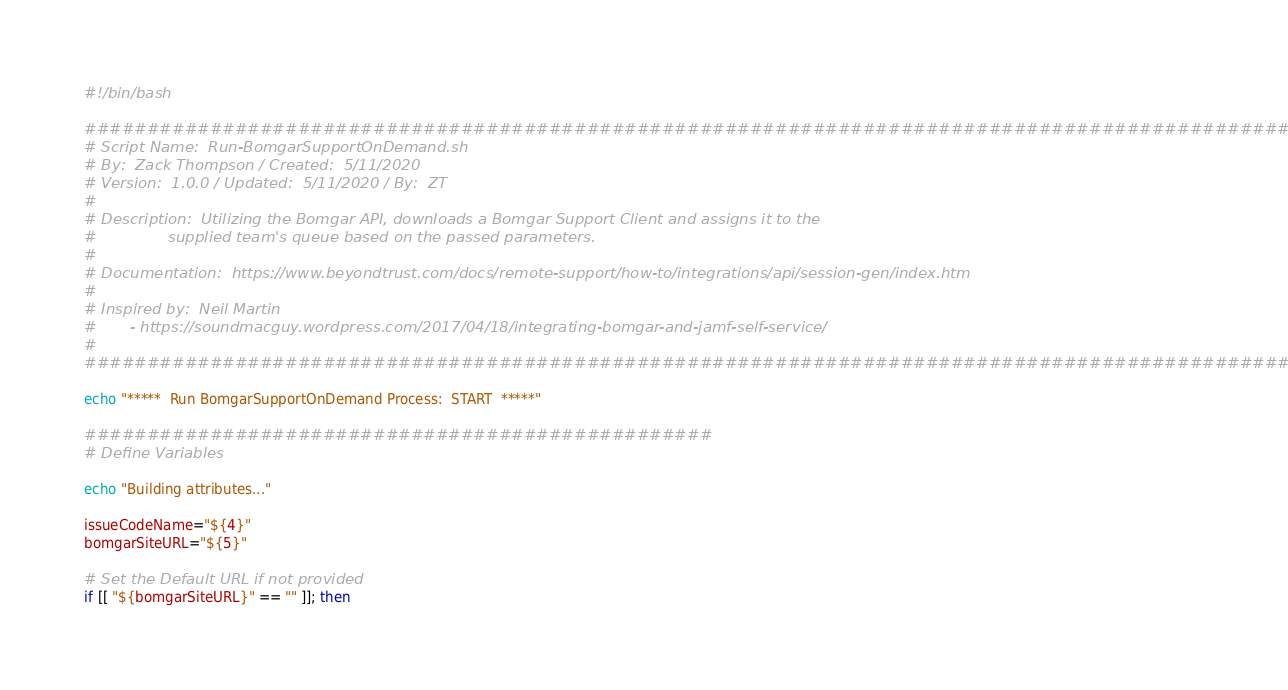Convert code to text. <code><loc_0><loc_0><loc_500><loc_500><_Bash_>#!/bin/bash

###################################################################################################
# Script Name:  Run-BomgarSupportOnDemand.sh
# By:  Zack Thompson / Created:  5/11/2020
# Version:  1.0.0 / Updated:  5/11/2020 / By:  ZT
#
# Description:  Utilizing the Bomgar API, downloads a Bomgar Support Client and assigns it to the
#               supplied team's queue based on the passed parameters.
#
# Documentation:  https://www.beyondtrust.com/docs/remote-support/how-to/integrations/api/session-gen/index.htm
#
# Inspired by:  Neil Martin
#       - https://soundmacguy.wordpress.com/2017/04/18/integrating-bomgar-and-jamf-self-service/
#
###################################################################################################

echo "*****  Run BomgarSupportOnDemand Process:  START  *****"

##################################################
# Define Variables

echo "Building attributes..."

issueCodeName="${4}"
bomgarSiteURL="${5}"

# Set the Default URL if not provided
if [[ "${bomgarSiteURL}" == "" ]]; then
</code> 